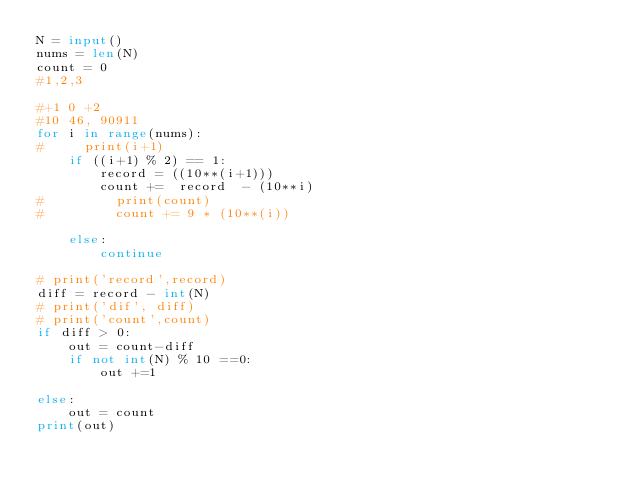<code> <loc_0><loc_0><loc_500><loc_500><_Python_>N = input()
nums = len(N)
count = 0
#1,2,3

#+1 0 +2
#10 46, 90911
for i in range(nums):
#     print(i+1)
    if ((i+1) % 2) == 1:
        record = ((10**(i+1)))
        count +=  record  - (10**i)
#         print(count)
#         count += 9 * (10**(i))
        
    else:
        continue

# print('record',record)
diff = record - int(N)
# print('dif', diff)
# print('count',count)
if diff > 0:
    out = count-diff
    if not int(N) % 10 ==0:
        out +=1
    
else:
    out = count
print(out)</code> 